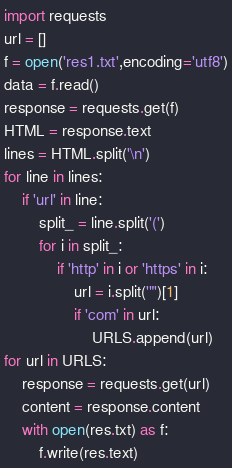<code> <loc_0><loc_0><loc_500><loc_500><_Python_>import requests
url = []
f = open('res1.txt',encoding='utf8')
data = f.read()
response = requests.get(f)
HTML = response.text
lines = HTML.split('\n')
for line in lines:
    if 'url' in line:
        split_ = line.split('(')
        for i in split_:
            if 'http' in i or 'https' in i:
                url = i.split('"')[1]
                if 'com' in url:
                    URLS.append(url)
for url in URLS:
    response = requests.get(url)
    content = response.content
    with open(res.txt) as f:
        f.write(res.text)</code> 